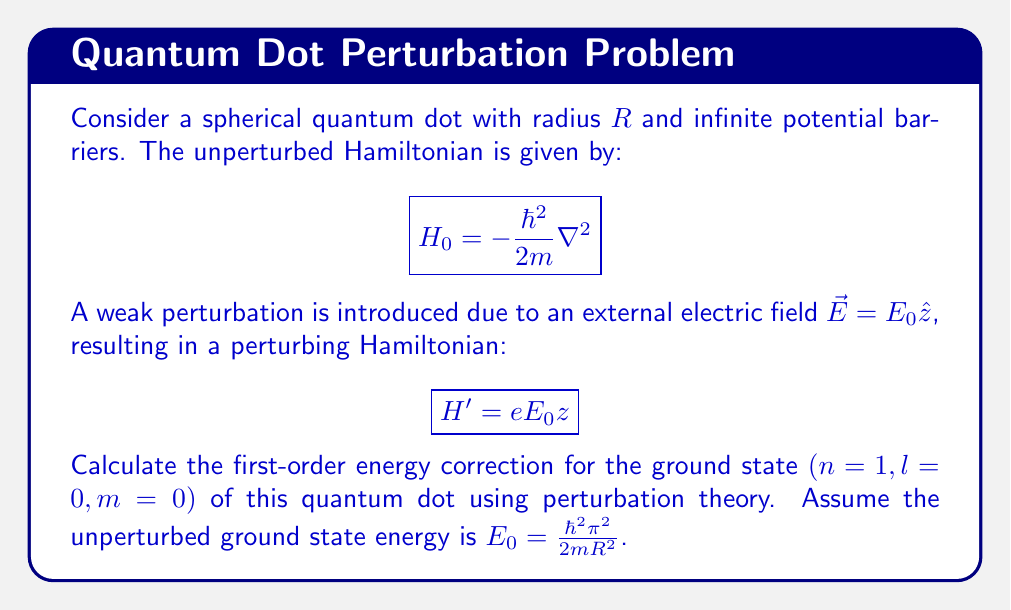Solve this math problem. To solve this problem, we'll follow these steps:

1) First, recall that the first-order energy correction in perturbation theory is given by:

   $$E^{(1)} = \langle \psi_0 | H' | \psi_0 \rangle$$

   where $\psi_0$ is the unperturbed ground state wavefunction.

2) For a spherical quantum dot with infinite barriers, the unperturbed ground state wavefunction is:

   $$\psi_0(r,\theta,\phi) = \frac{1}{\sqrt{2\pi R^3}}\frac{\sin(\pi r/R)}{r}$$

3) The perturbing Hamiltonian is $H' = eE_0z$. In spherical coordinates, $z = r\cos\theta$.

4) Now, we need to evaluate:

   $$E^{(1)} = eE_0 \int_0^R \int_0^\pi \int_0^{2\pi} \psi_0^*(r,\theta,\phi) \cdot r\cos\theta \cdot \psi_0(r,\theta,\phi) \cdot r^2\sin\theta \, d\phi \, d\theta \, dr$$

5) Substituting the wavefunction:

   $$E^{(1)} = eE_0 \int_0^R \int_0^\pi \int_0^{2\pi} \frac{1}{2\pi R^3}\frac{\sin^2(\pi r/R)}{r^2} \cdot r\cos\theta \cdot r^2\sin\theta \, d\phi \, d\theta \, dr$$

6) The $\phi$ integral gives $2\pi$. For the $\theta$ integral, note that $\int_0^\pi \cos\theta \sin\theta \, d\theta = 0$.

7) Therefore, the first-order energy correction is zero:

   $$E^{(1)} = 0$$

This result is due to the symmetry of the ground state wavefunction. The perturbation shifts the energy levels up on one side of the z-axis and down on the other, canceling out for the spherically symmetric ground state.
Answer: $E^{(1)} = 0$ 